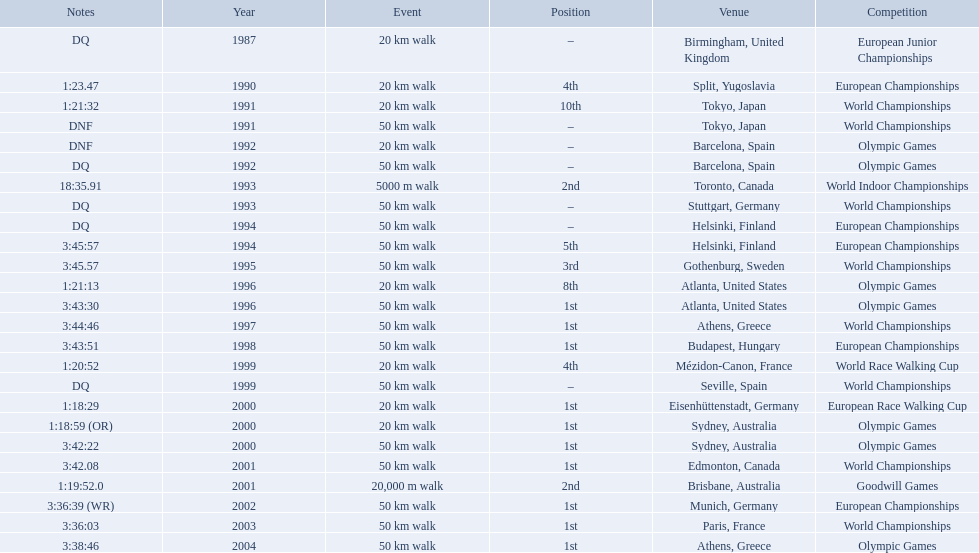Which of the competitions were 50 km walks? World Championships, Olympic Games, World Championships, European Championships, European Championships, World Championships, Olympic Games, World Championships, European Championships, World Championships, Olympic Games, World Championships, European Championships, World Championships, Olympic Games. Of these, which took place during or after the year 2000? Olympic Games, World Championships, European Championships, World Championships, Olympic Games. From these, which took place in athens, greece? Olympic Games. What was the time to finish for this competition? 3:38:46. 